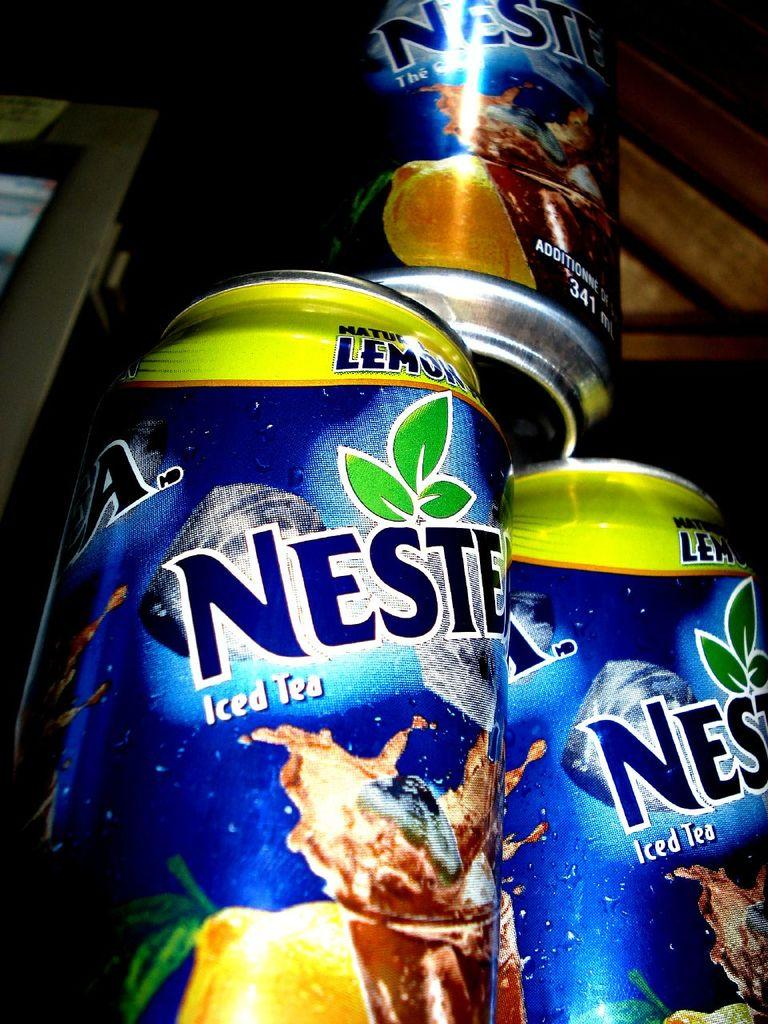<image>
Describe the image concisely. The blue can of iced tea contains 341 ml of the beverage. 